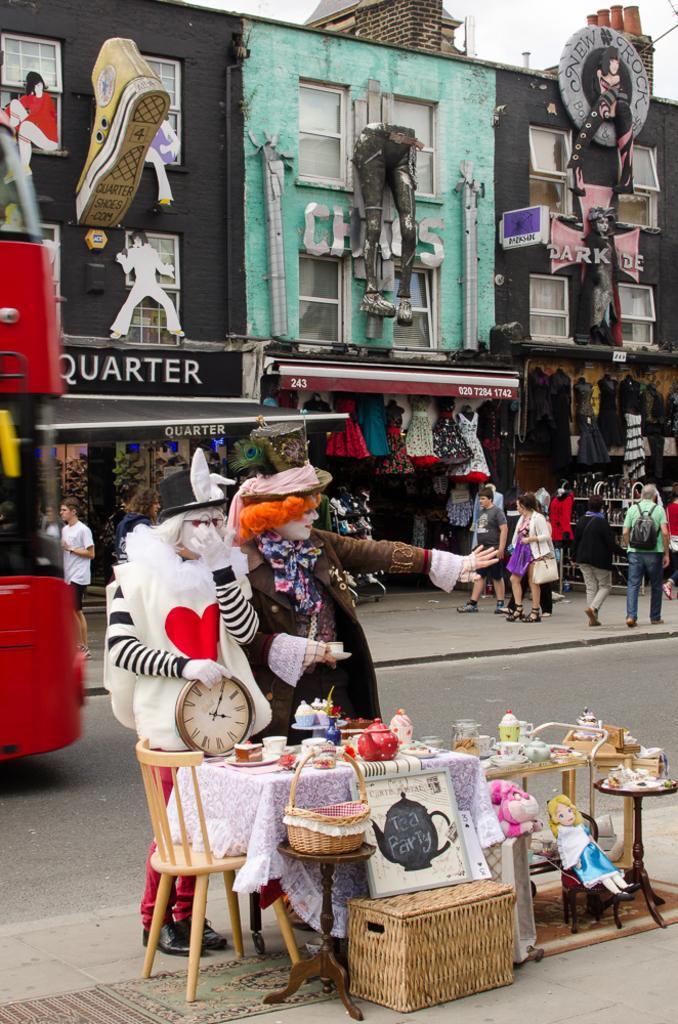In one or two sentences, can you explain what this image depicts? Here there are two persons standing at the table. On the table we can see toys,cups and jars. Beside the table there is a chair and a basket. In the background there are buildings,stores and few people. 